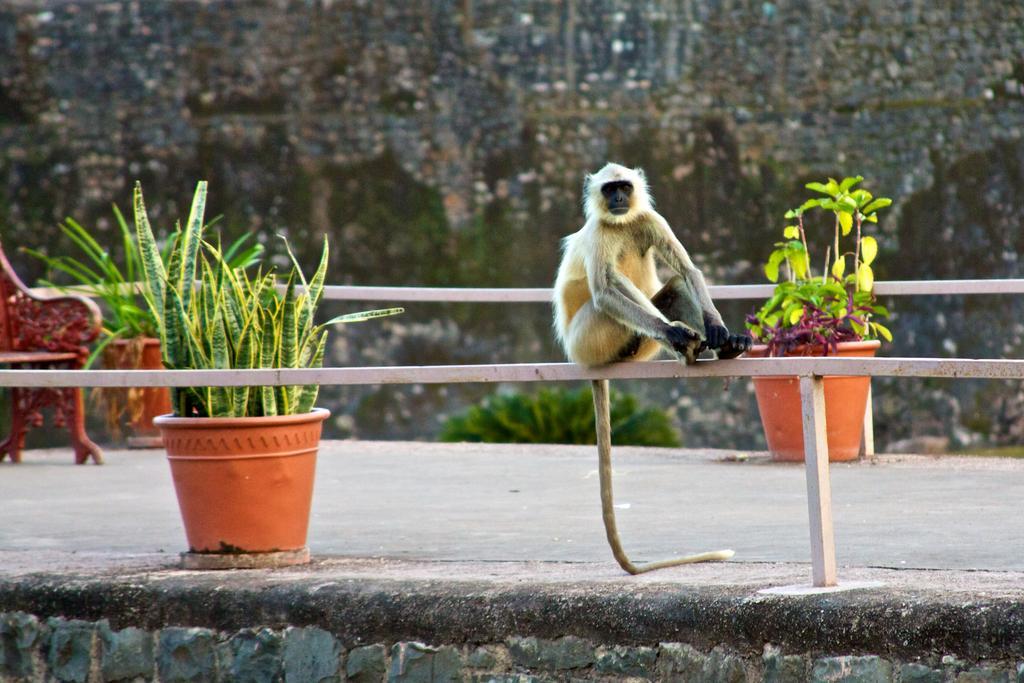In one or two sentences, can you explain what this image depicts? In this picture, we can see monkey is sitting on an iron rod and behind the monkey there are pots with plants, bench and a wall. 